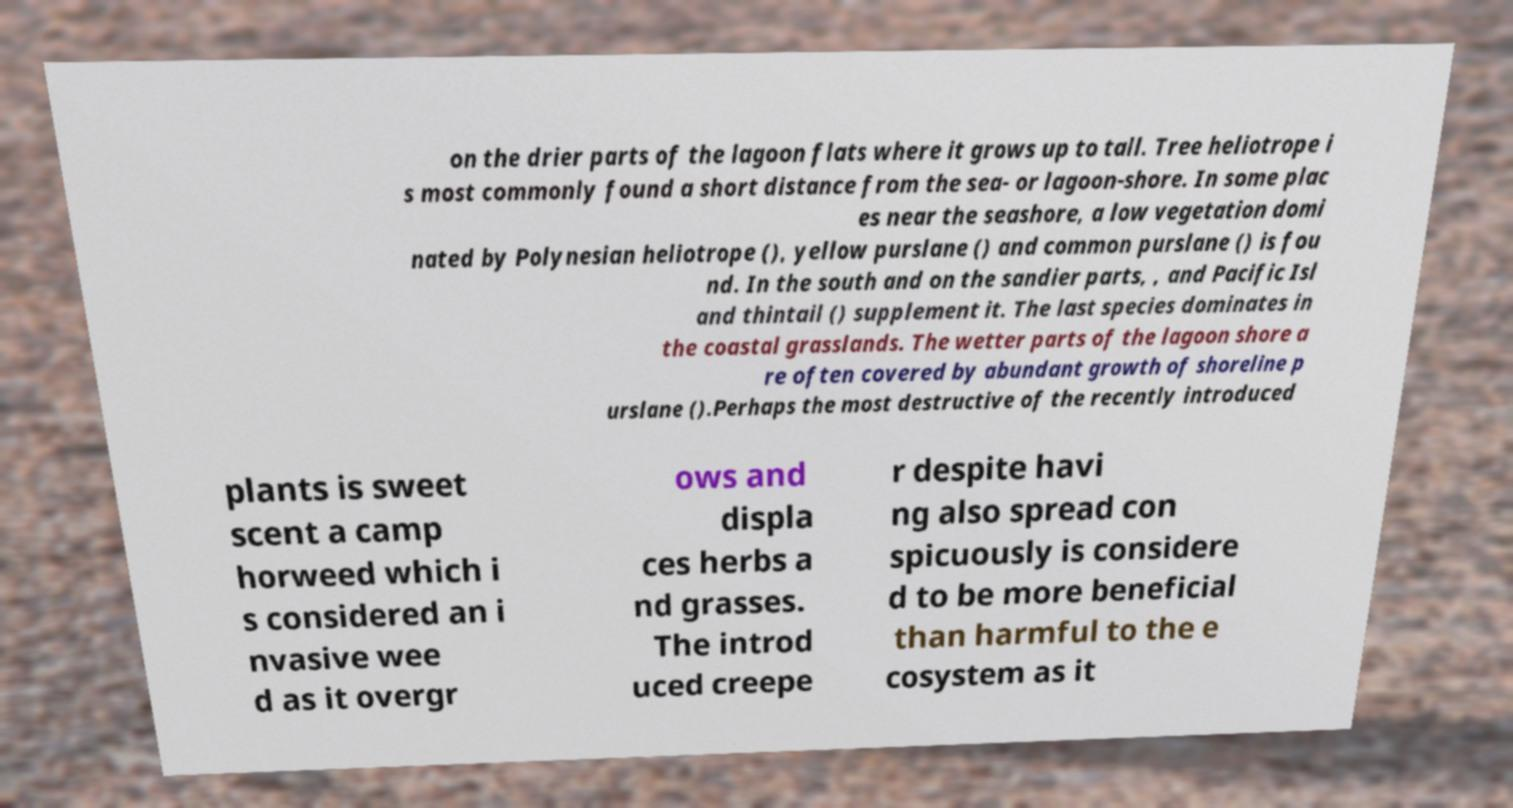There's text embedded in this image that I need extracted. Can you transcribe it verbatim? on the drier parts of the lagoon flats where it grows up to tall. Tree heliotrope i s most commonly found a short distance from the sea- or lagoon-shore. In some plac es near the seashore, a low vegetation domi nated by Polynesian heliotrope (), yellow purslane () and common purslane () is fou nd. In the south and on the sandier parts, , and Pacific Isl and thintail () supplement it. The last species dominates in the coastal grasslands. The wetter parts of the lagoon shore a re often covered by abundant growth of shoreline p urslane ().Perhaps the most destructive of the recently introduced plants is sweet scent a camp horweed which i s considered an i nvasive wee d as it overgr ows and displa ces herbs a nd grasses. The introd uced creepe r despite havi ng also spread con spicuously is considere d to be more beneficial than harmful to the e cosystem as it 